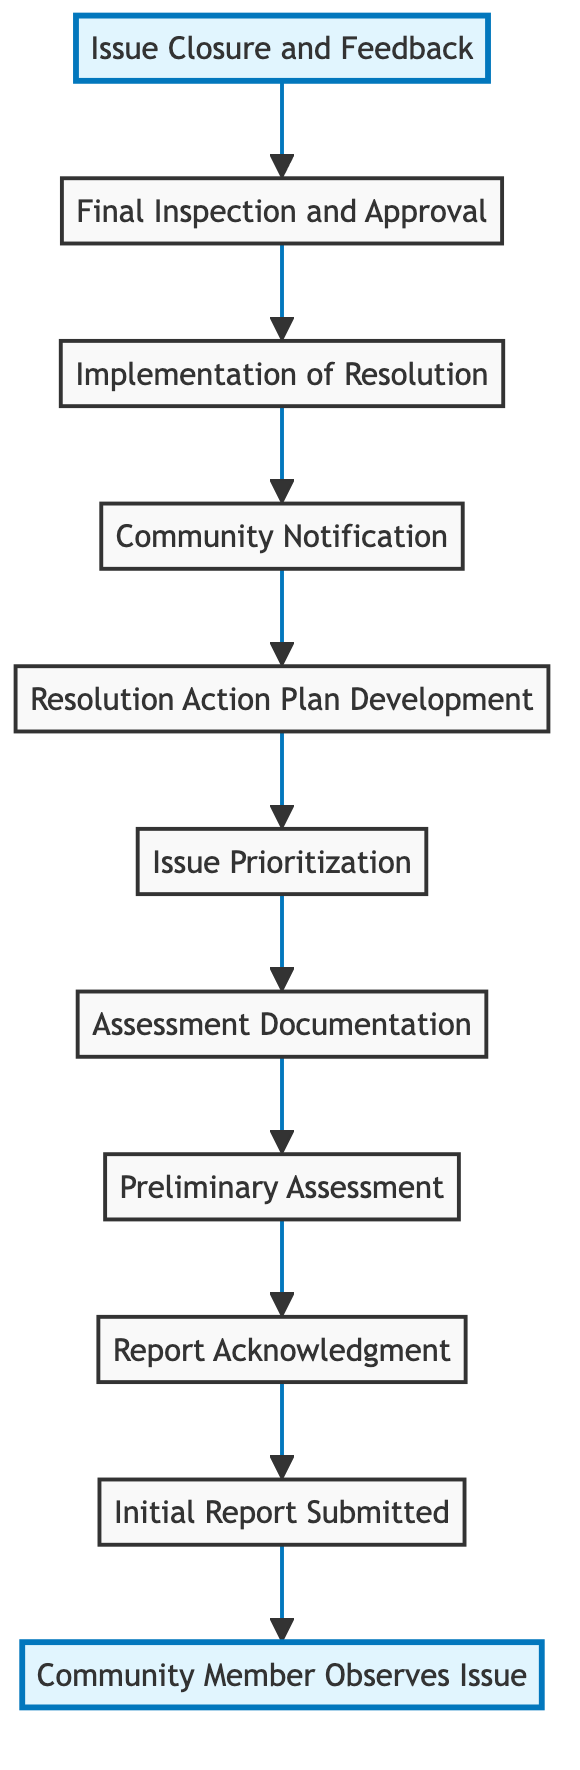What is the first step in the pathway for reporting unsafe infrastructure? The first step is "Community Member Observes Issue," where a resident notices a problem.
Answer: Community Member Observes Issue How many nodes are in the flowchart? The flowchart contains 11 nodes, including all steps from observation to closure and feedback.
Answer: 11 Which step follows "Initial Report Submitted"? After the "Initial Report Submitted" step, the next step is "Report Acknowledgment."
Answer: Report Acknowledgment What step involves a municipal worker inspecting the reported issue? The step where a municipal worker inspects the reported issue is "Preliminary Assessment."
Answer: Preliminary Assessment What is documented right after the preliminary assessment? After the "Preliminary Assessment," the findings are documented in the "Assessment Documentation" step.
Answer: Assessment Documentation Which action is taken after the community is notified? After the community is notified, "Implementation of Resolution" is carried out to fix the infrastructure issue.
Answer: Implementation of Resolution What is the purpose of the "Issue Closure and Feedback" step? The purpose of the "Issue Closure and Feedback" step is to mark the issue as resolved and provide feedback opportunities to the resident.
Answer: Issue Closure and Feedback How does the "Resolution Action Plan Development" relate to "Issue Prioritization"? "Resolution Action Plan Development" follows "Issue Prioritization," meaning the issue needs to be prioritized before developing the action plan.
Answer: Follow-up step What role does the community notification play in the overall process? Community notification informs residents about the planned actions and timeline after a resolution plan is developed.
Answer: Informing community What is the endpoint of the flowchart? The endpoint of the flowchart is "Issue Closure and Feedback," marking the completion of the reporting process.
Answer: Issue Closure and Feedback 